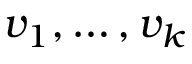<formula> <loc_0><loc_0><loc_500><loc_500>v _ { 1 } , \dots , v _ { k }</formula> 